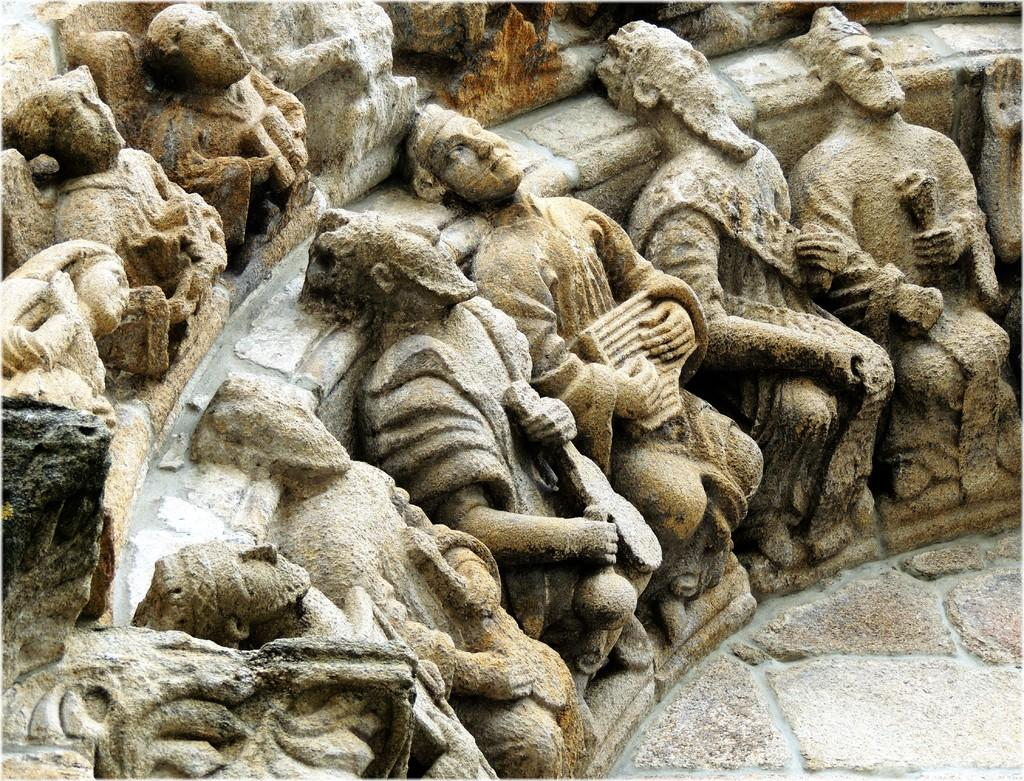What type of objects are depicted in the image? There are statues of people in the image. Can you describe the colors of the statues? The statues are in brown and ash colors. Can you tell me how many people are sleeping near the statues in the image? There is no mention of people sleeping near the statues in the image; the image only features the statues themselves. 